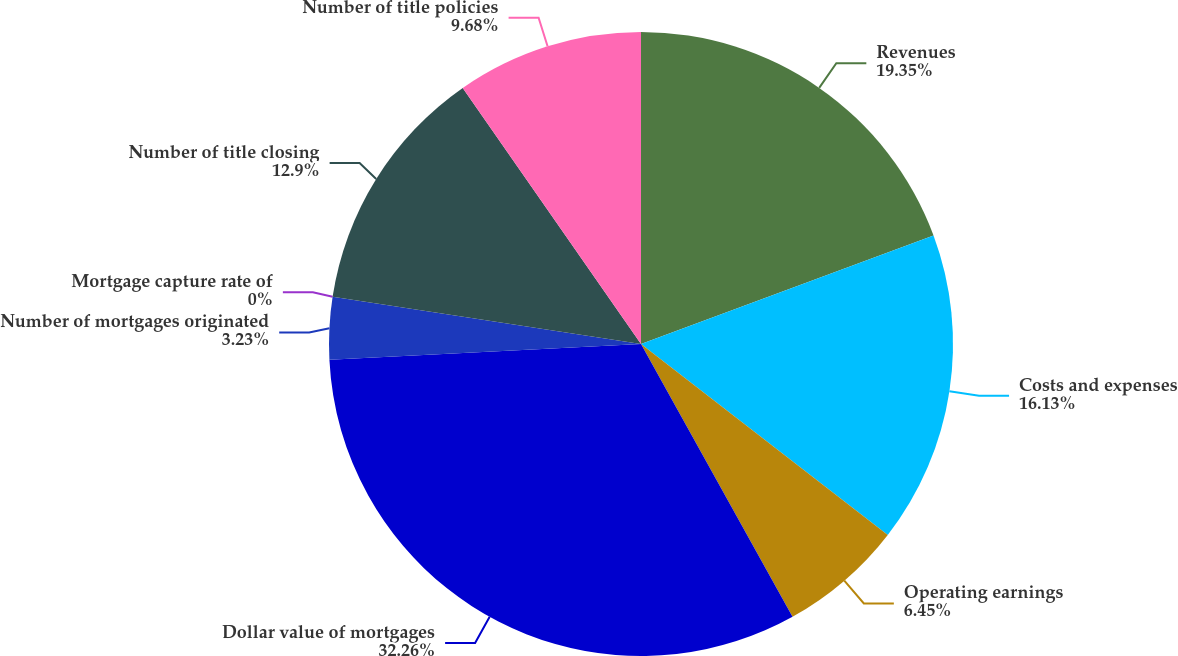Convert chart to OTSL. <chart><loc_0><loc_0><loc_500><loc_500><pie_chart><fcel>Revenues<fcel>Costs and expenses<fcel>Operating earnings<fcel>Dollar value of mortgages<fcel>Number of mortgages originated<fcel>Mortgage capture rate of<fcel>Number of title closing<fcel>Number of title policies<nl><fcel>19.35%<fcel>16.13%<fcel>6.45%<fcel>32.26%<fcel>3.23%<fcel>0.0%<fcel>12.9%<fcel>9.68%<nl></chart> 